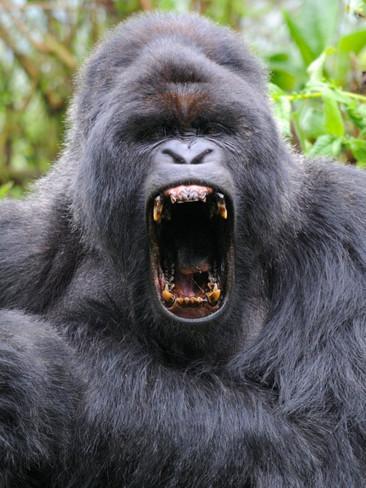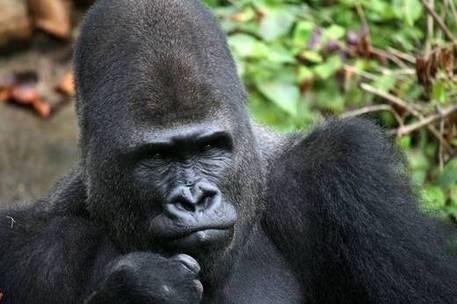The first image is the image on the left, the second image is the image on the right. Evaluate the accuracy of this statement regarding the images: "There is one gorilla with its mouth wide open showing all of its teeth.". Is it true? Answer yes or no. Yes. The first image is the image on the left, the second image is the image on the right. Examine the images to the left and right. Is the description "Each image shows just one ape, and one of the apes has an open mouth." accurate? Answer yes or no. Yes. 